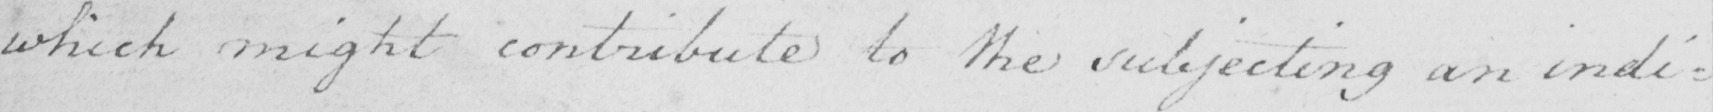What does this handwritten line say? which might contribute to the subjecting an indi= 